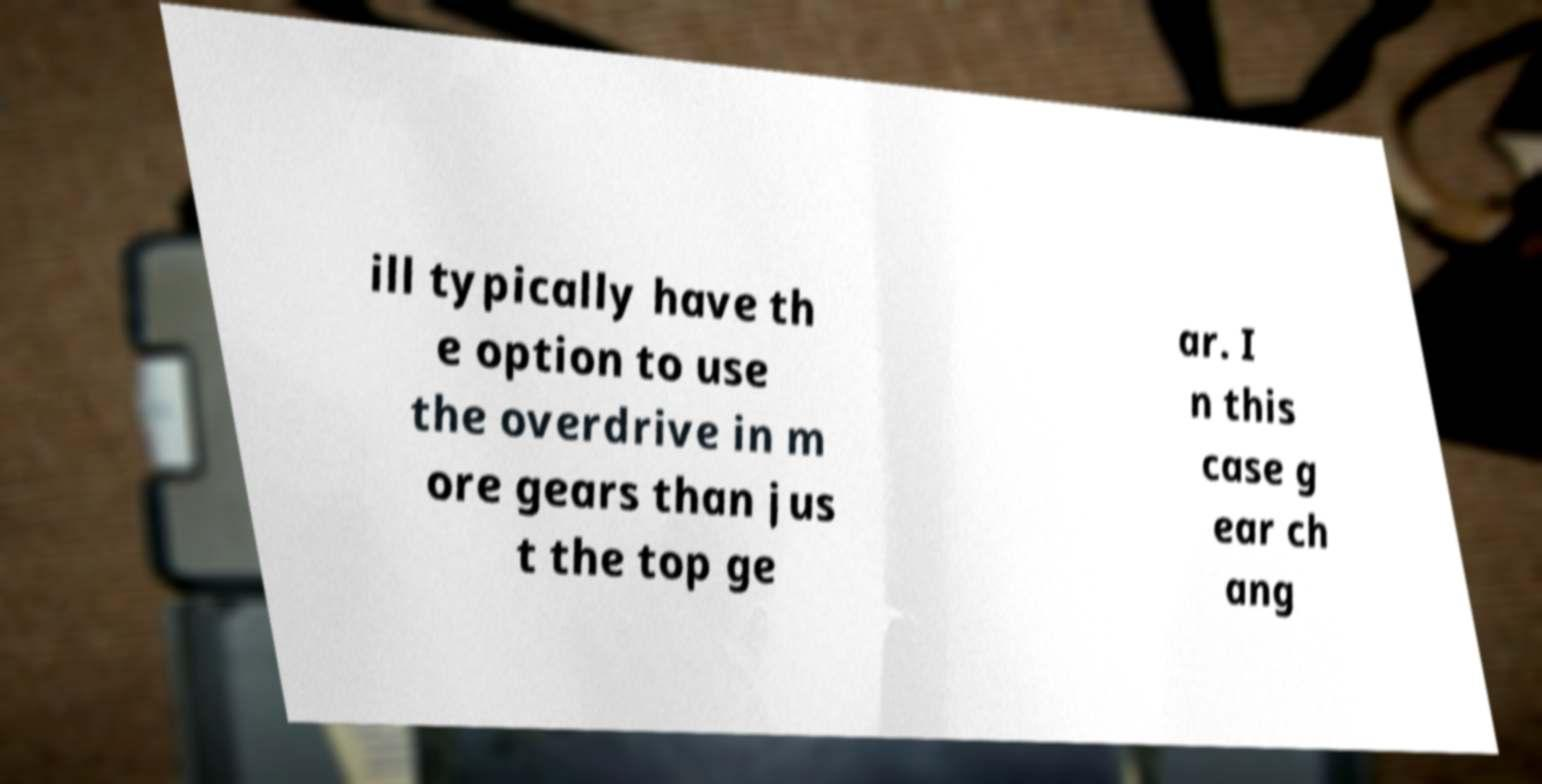What messages or text are displayed in this image? I need them in a readable, typed format. ill typically have th e option to use the overdrive in m ore gears than jus t the top ge ar. I n this case g ear ch ang 